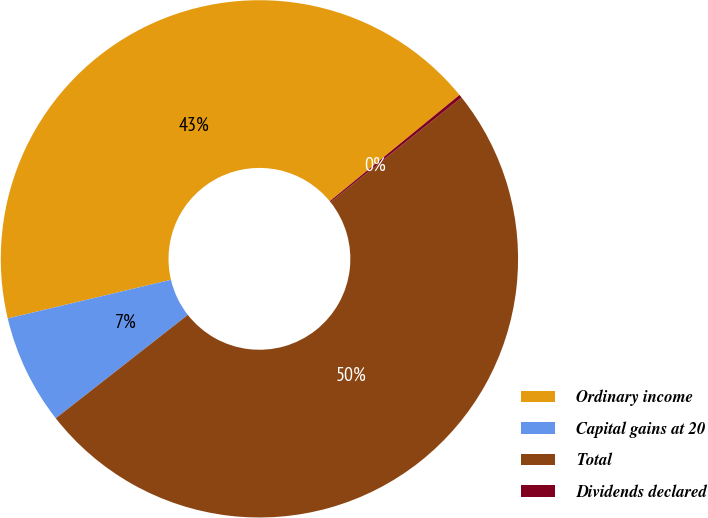<chart> <loc_0><loc_0><loc_500><loc_500><pie_chart><fcel>Ordinary income<fcel>Capital gains at 20<fcel>Total<fcel>Dividends declared<nl><fcel>42.78%<fcel>6.87%<fcel>50.15%<fcel>0.2%<nl></chart> 